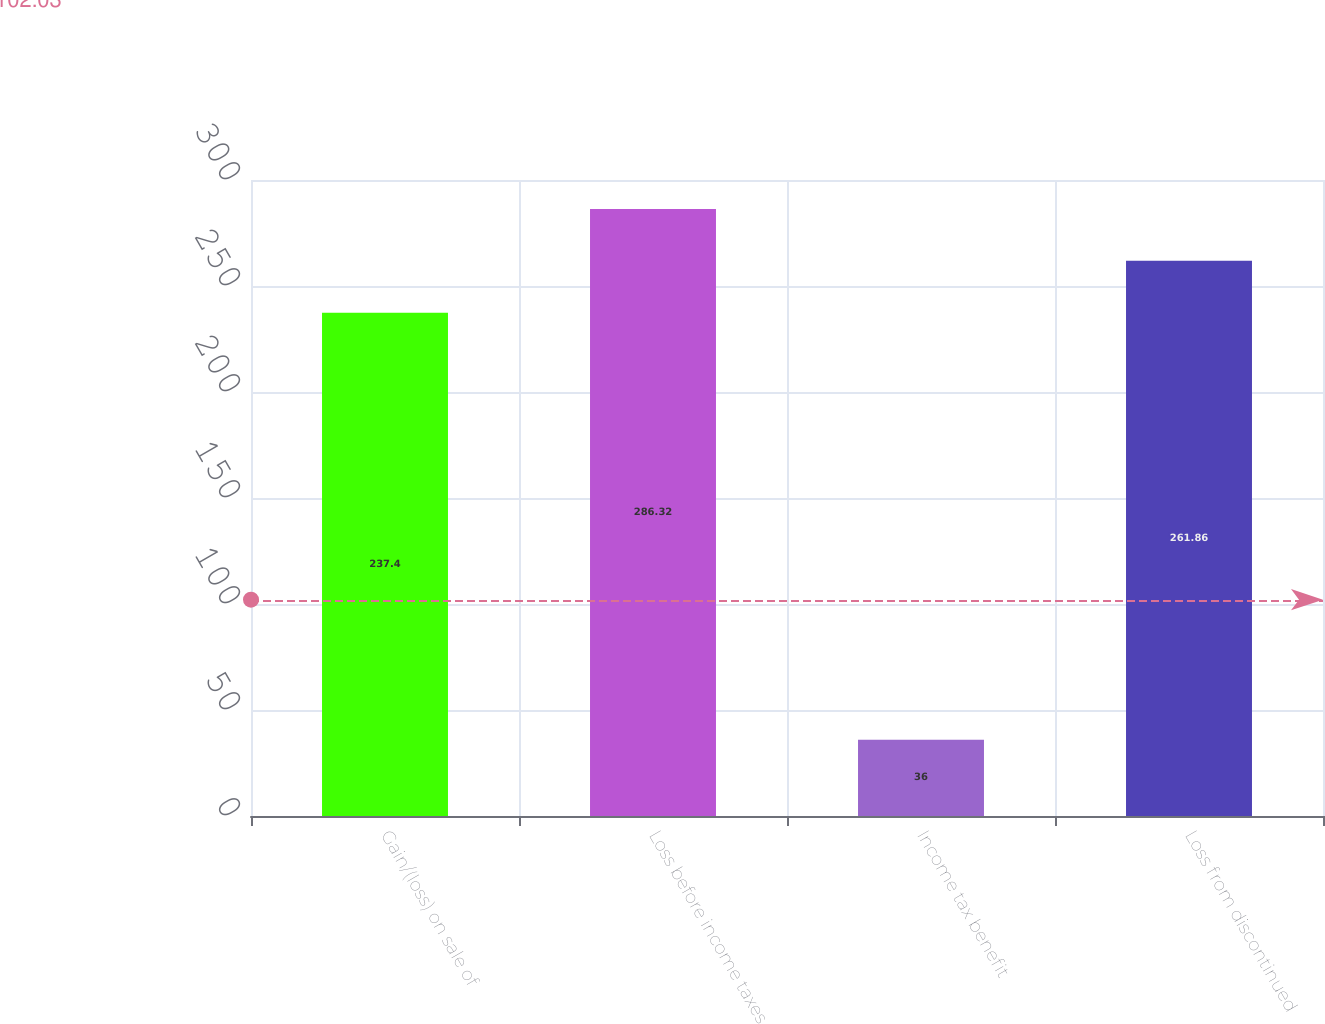<chart> <loc_0><loc_0><loc_500><loc_500><bar_chart><fcel>Gain/(loss) on sale of<fcel>Loss before income taxes<fcel>Income tax benefit<fcel>Loss from discontinued<nl><fcel>237.4<fcel>286.32<fcel>36<fcel>261.86<nl></chart> 